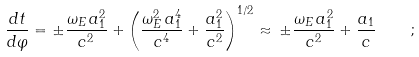<formula> <loc_0><loc_0><loc_500><loc_500>\frac { d t } { d \varphi } = \pm \frac { \omega _ { E } \, a _ { 1 } ^ { 2 } } { c ^ { 2 } } + \left ( \frac { \omega _ { E } ^ { 2 } \, a _ { 1 } ^ { 4 } } { c ^ { 4 } } + \frac { a _ { 1 } ^ { 2 } } { c ^ { 2 } } \right ) ^ { 1 / 2 } \approx \, \pm \frac { \omega _ { E } \, a _ { 1 } ^ { 2 } } { c ^ { 2 } } + \frac { a _ { 1 } } { c } \quad ;</formula> 